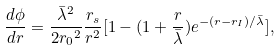Convert formula to latex. <formula><loc_0><loc_0><loc_500><loc_500>\frac { d { \phi } } { d r } = \frac { { \bar { \lambda } } ^ { 2 } } { 2 { r _ { 0 } } ^ { 2 } } \frac { r _ { s } } { r ^ { 2 } } [ 1 - ( 1 + \frac { r } { \bar { \lambda } } ) e ^ { - ( r - r _ { I } ) / \bar { \lambda } } ] ,</formula> 